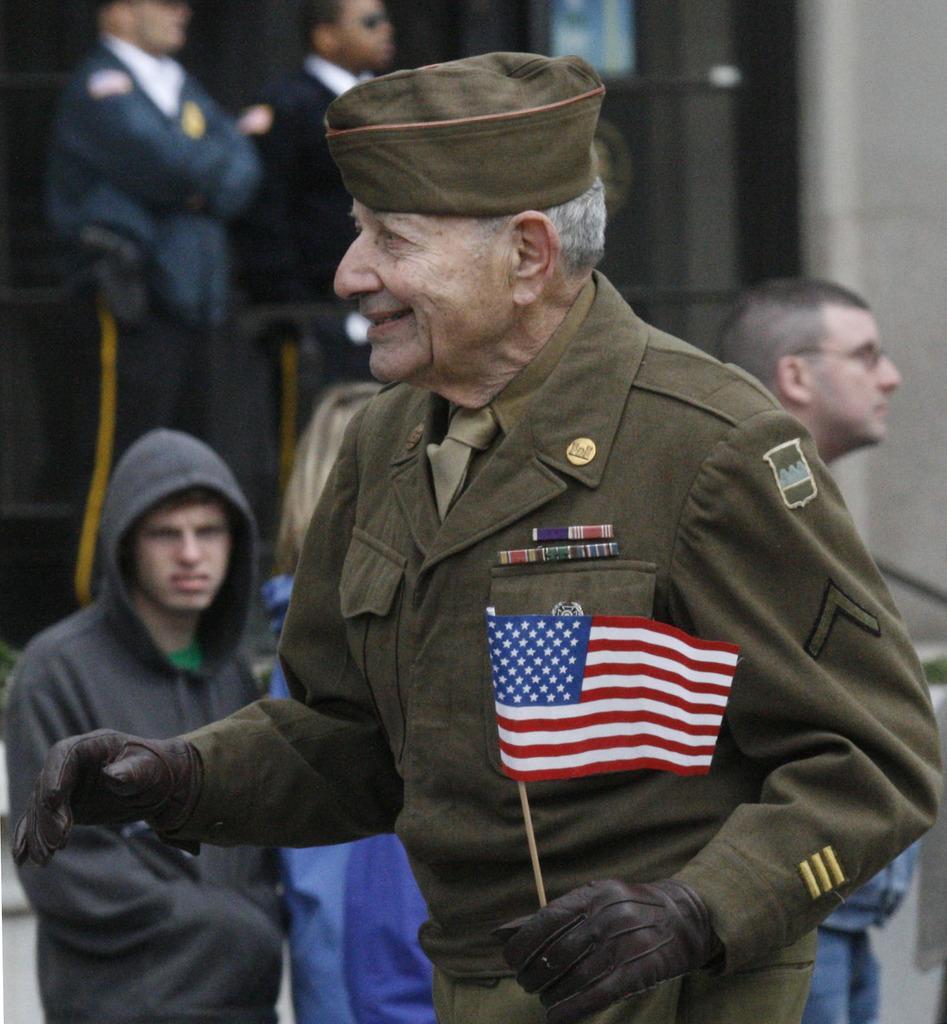Please provide a concise description of this image. In this image I can see there is an old man standing and he is wearing a uniform and holding the flag. There are few other people in the background and the background of the image is blurred. 